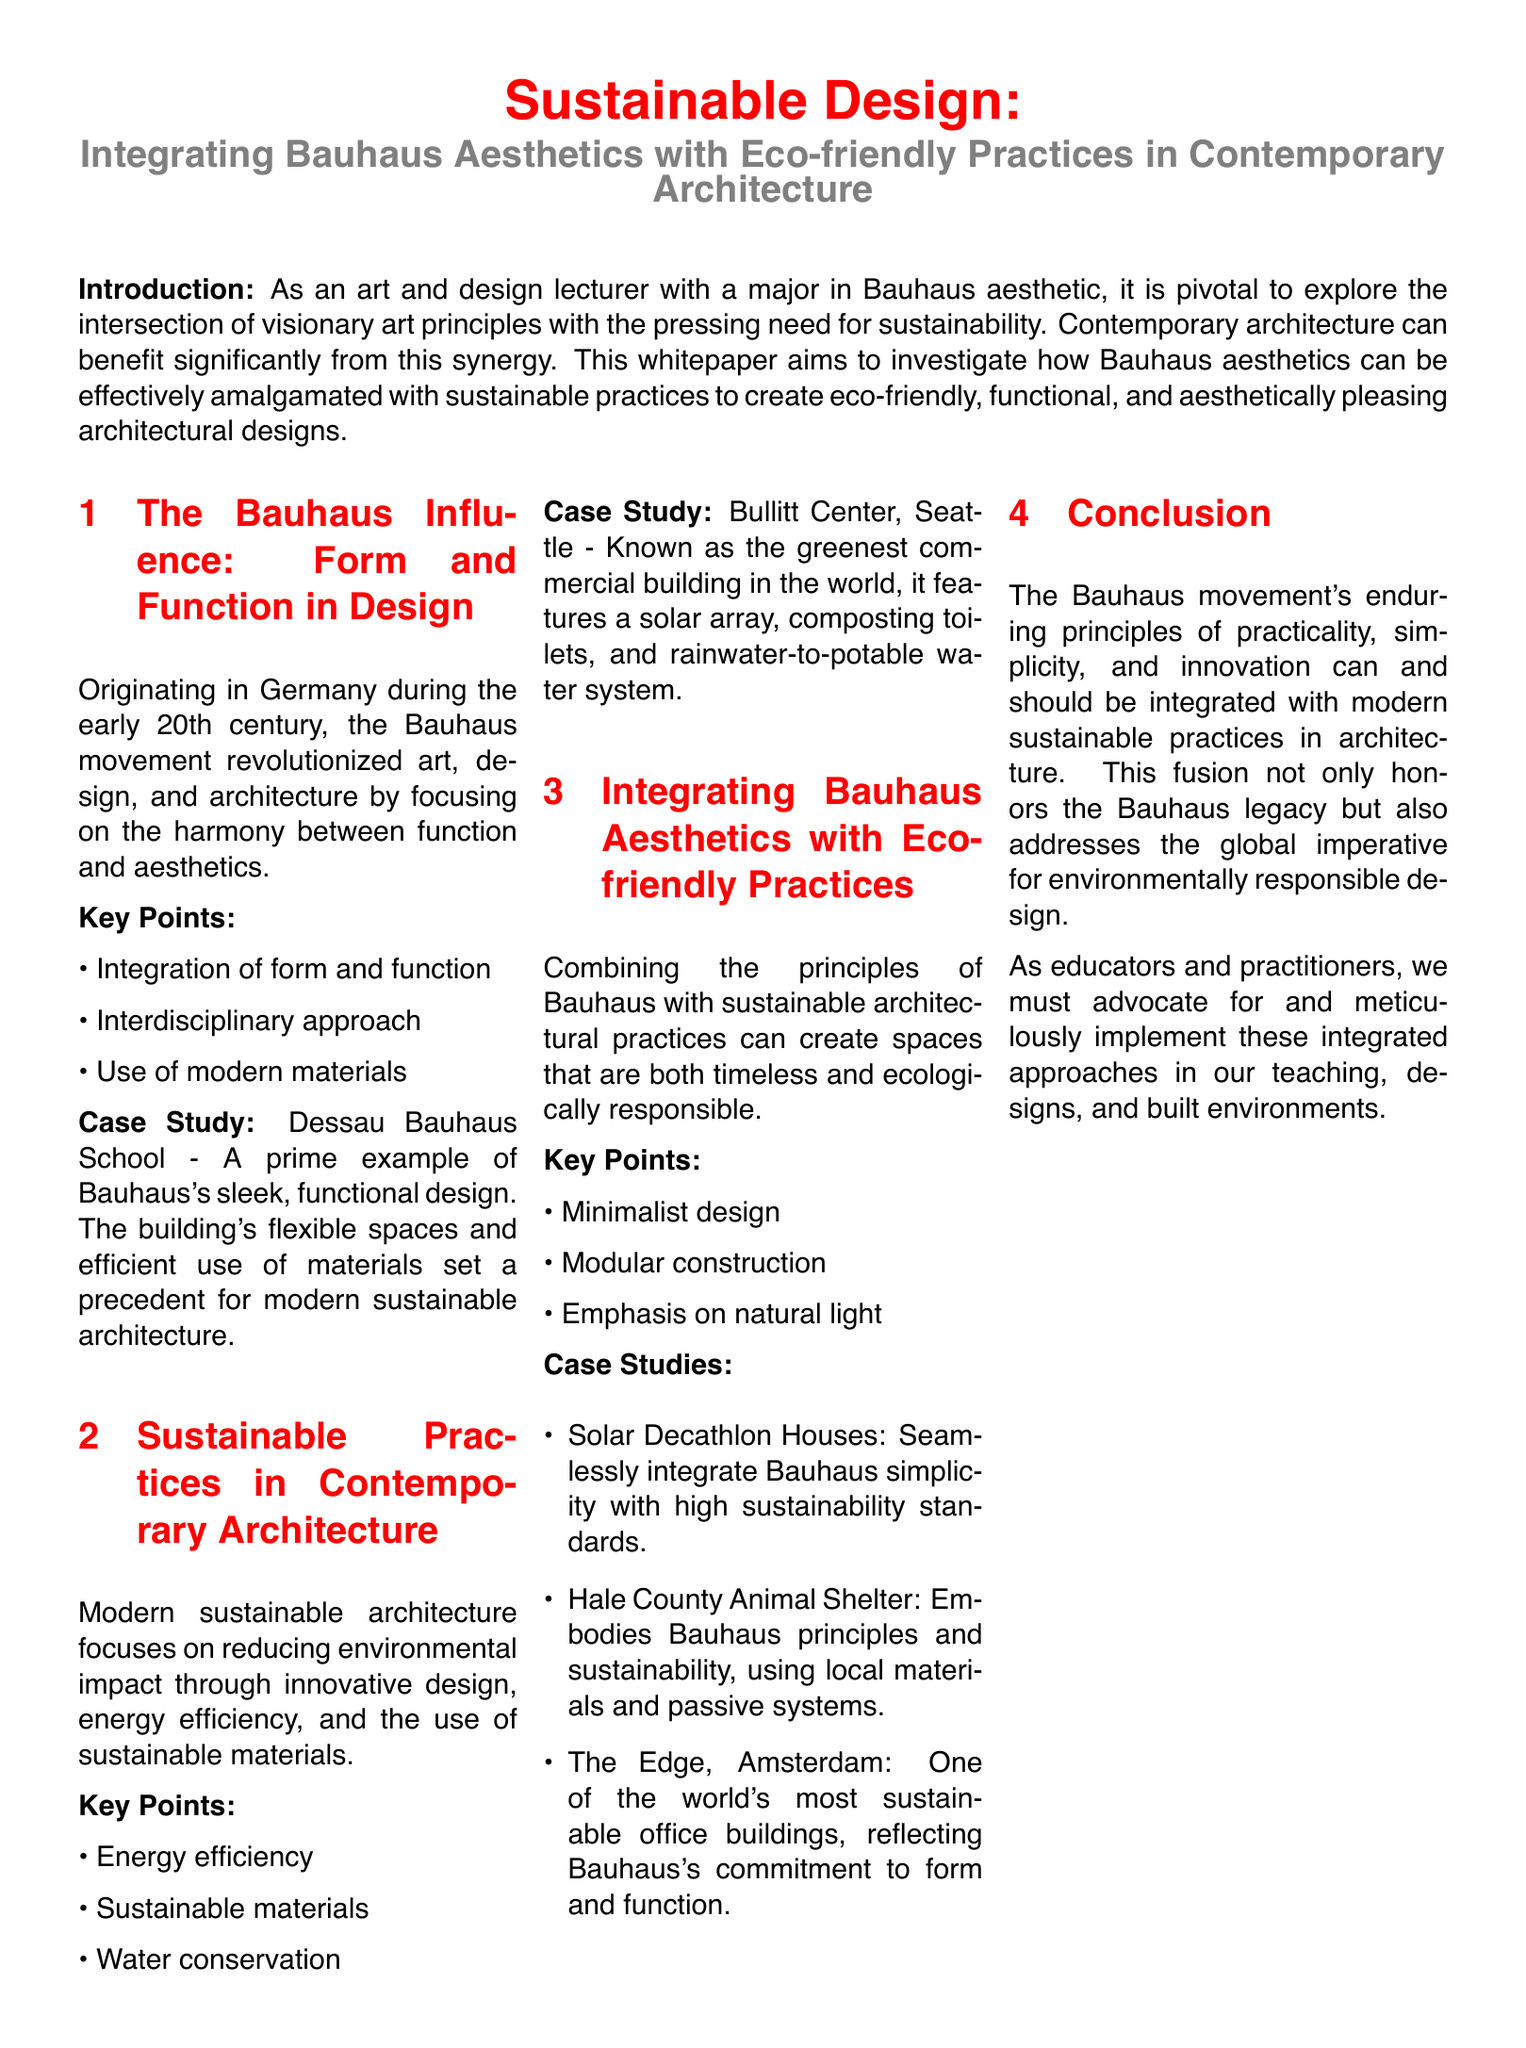What is the title of the whitepaper? The title is stated prominently at the beginning of the document.
Answer: Sustainable Design: Integrating Bauhaus Aesthetics with Eco-friendly Practices in Contemporary Architecture Where did the Bauhaus movement originate? The document mentions the origin of the Bauhaus movement in the introductory section.
Answer: Germany What are two key points of the Bauhaus influence? The key points listed under the Bauhaus Influence section provide this information.
Answer: Integration of form and function; Interdisciplinary approach Which building is referred to as the greenest commercial building in the world? The case study section includes a specific building known for its sustainability.
Answer: Bullitt Center What design principle emphasizes using local materials and passive systems? The document highlights the principles embodied by the Hale County Animal Shelter case study.
Answer: Bauhaus principles and sustainability Name one of the case studies that integrate Bauhaus simplicity with sustainability. The case study section lists various examples that illustrate this integration.
Answer: Solar Decathlon Houses How does the document suggest we should advocate for integrated approaches? The conclusion section discusses advocacy for practices in teaching and design.
Answer: Meticulously implement these integrated approaches What aspect of contemporary architecture focuses on reducing environmental impact? The Sustainable Practices section mentions a focus on certain architectural aspects.
Answer: Innovative design Which city is mentioned in the context of a sustainable office building? The document includes a case study located in a specific city.
Answer: Amsterdam 